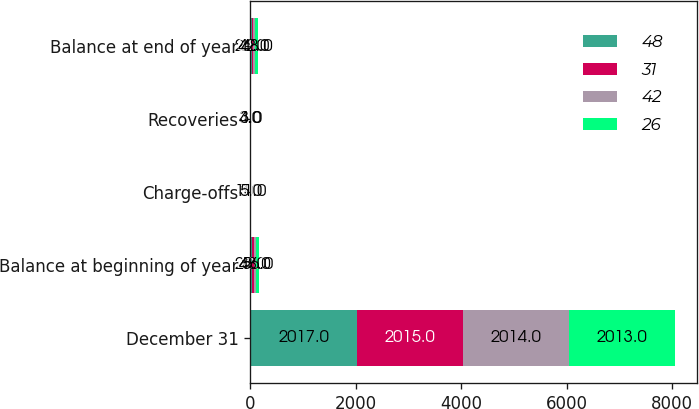Convert chart. <chart><loc_0><loc_0><loc_500><loc_500><stacked_bar_chart><ecel><fcel>December 31<fcel>Balance at beginning of year<fcel>Charge-offs<fcel>Recoveries<fcel>Balance at end of year<nl><fcel>48<fcel>2017<fcel>26<fcel>3<fcel>3<fcel>26<nl><fcel>31<fcel>2015<fcel>42<fcel>3<fcel>3<fcel>31<nl><fcel>42<fcel>2014<fcel>48<fcel>5<fcel>3<fcel>42<nl><fcel>26<fcel>2013<fcel>56<fcel>11<fcel>4<fcel>48<nl></chart> 